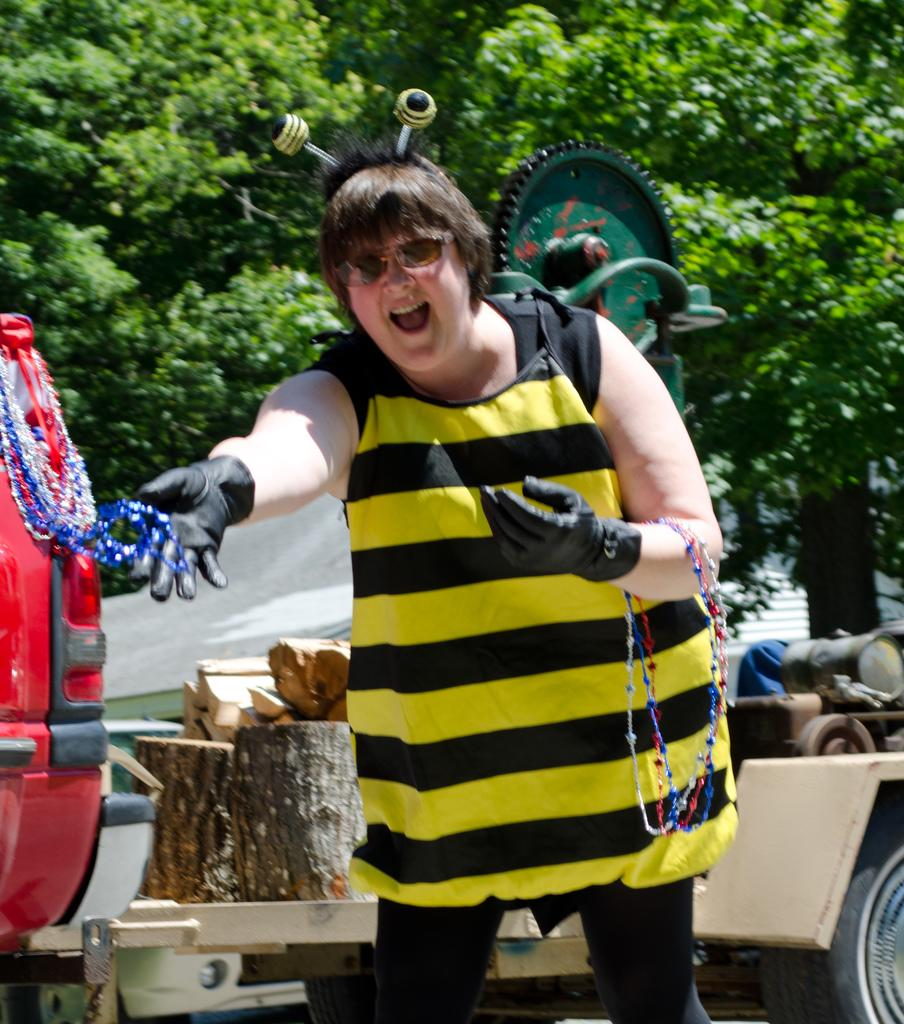Who is present in the image? There is a woman in the image. What is the woman wearing? The woman is wearing spectacles. What is the woman's posture in the image? The woman is standing. What type of objects can be seen in the image? There are vehicles, trees, wood, and a machine in the image. What type of ornament is the woman holding in the image? There is no ornament present in the image. How many seats are visible in the image? There is no mention of seats in the image. 